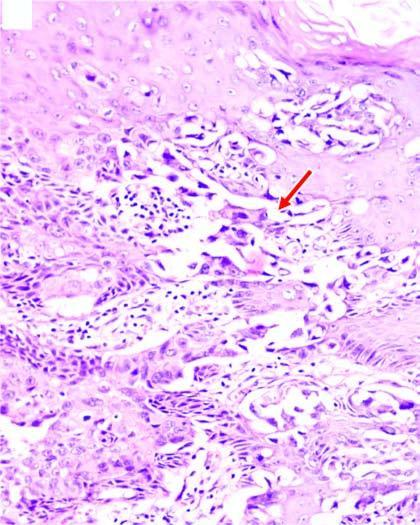what are in the epidermal layers containing large tumour cells?
Answer the question using a single word or phrase. Clefts 